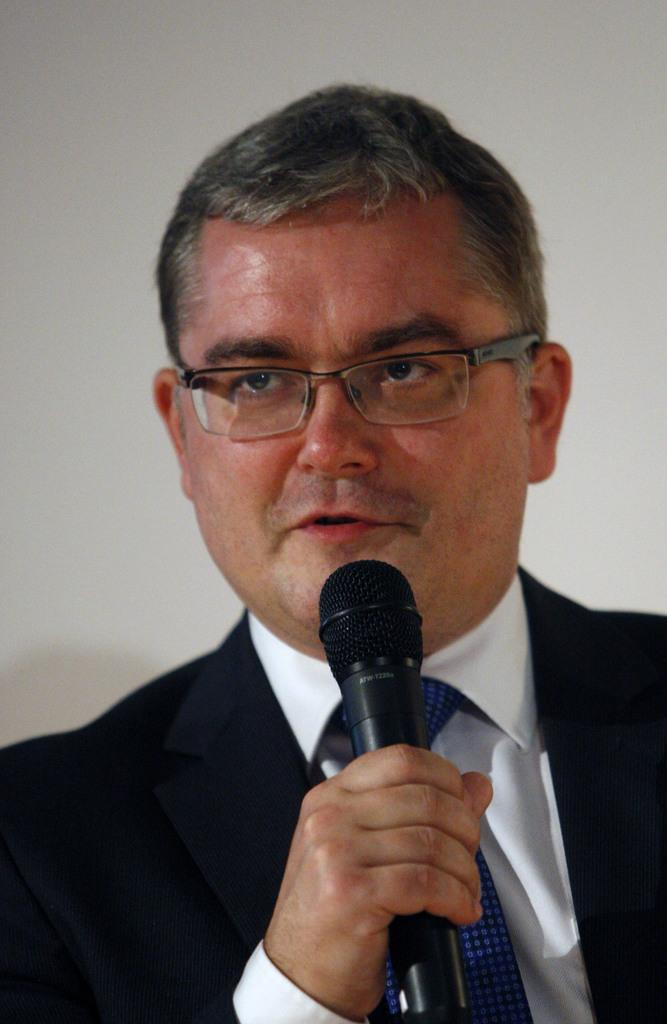What object is the person holding in the image? The person is holding a microphone. What accessory is the person wearing on their face? The person is wearing glasses. What type of clothing is the person wearing around their neck? The person is wearing a tie. How many cakes are being shared among the friends in the image? There are no cakes or friends present in the image; it only features a person holding a microphone and wearing glasses and a tie. 